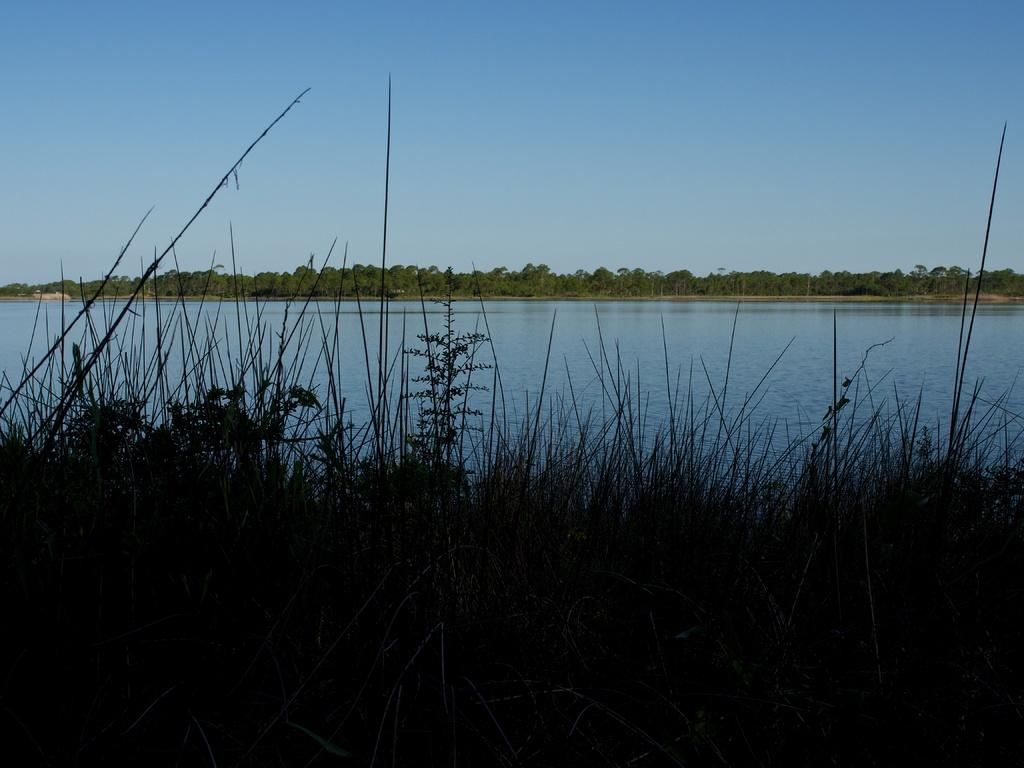What type of living organisms can be seen in the image? Plants can be seen in the image. What is the primary element present in the image? There is water in the image. What can be seen in the background of the image? There are trees in the background of the image. What is visible above the trees in the background? The sky is visible above the trees in the background. Where is the shelf located in the image? There is no shelf present in the image. What does the tongue of the plant look like in the image? There are no tongues present in the image, as plants do not have tongues. 